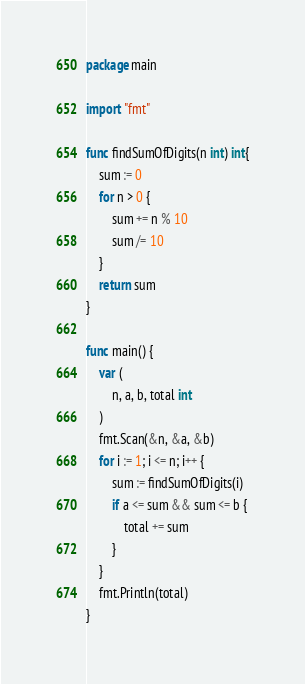Convert code to text. <code><loc_0><loc_0><loc_500><loc_500><_Go_>package main

import "fmt"

func findSumOfDigits(n int) int{
	sum := 0
	for n > 0 {
		sum += n % 10
		sum /= 10
	}
	return sum
}

func main() {
	var (
		n, a, b, total int
	)
	fmt.Scan(&n, &a, &b)
	for i := 1; i <= n; i++ {
		sum := findSumOfDigits(i)
		if a <= sum && sum <= b {
			total += sum
		}
	}
	fmt.Println(total)
}
</code> 